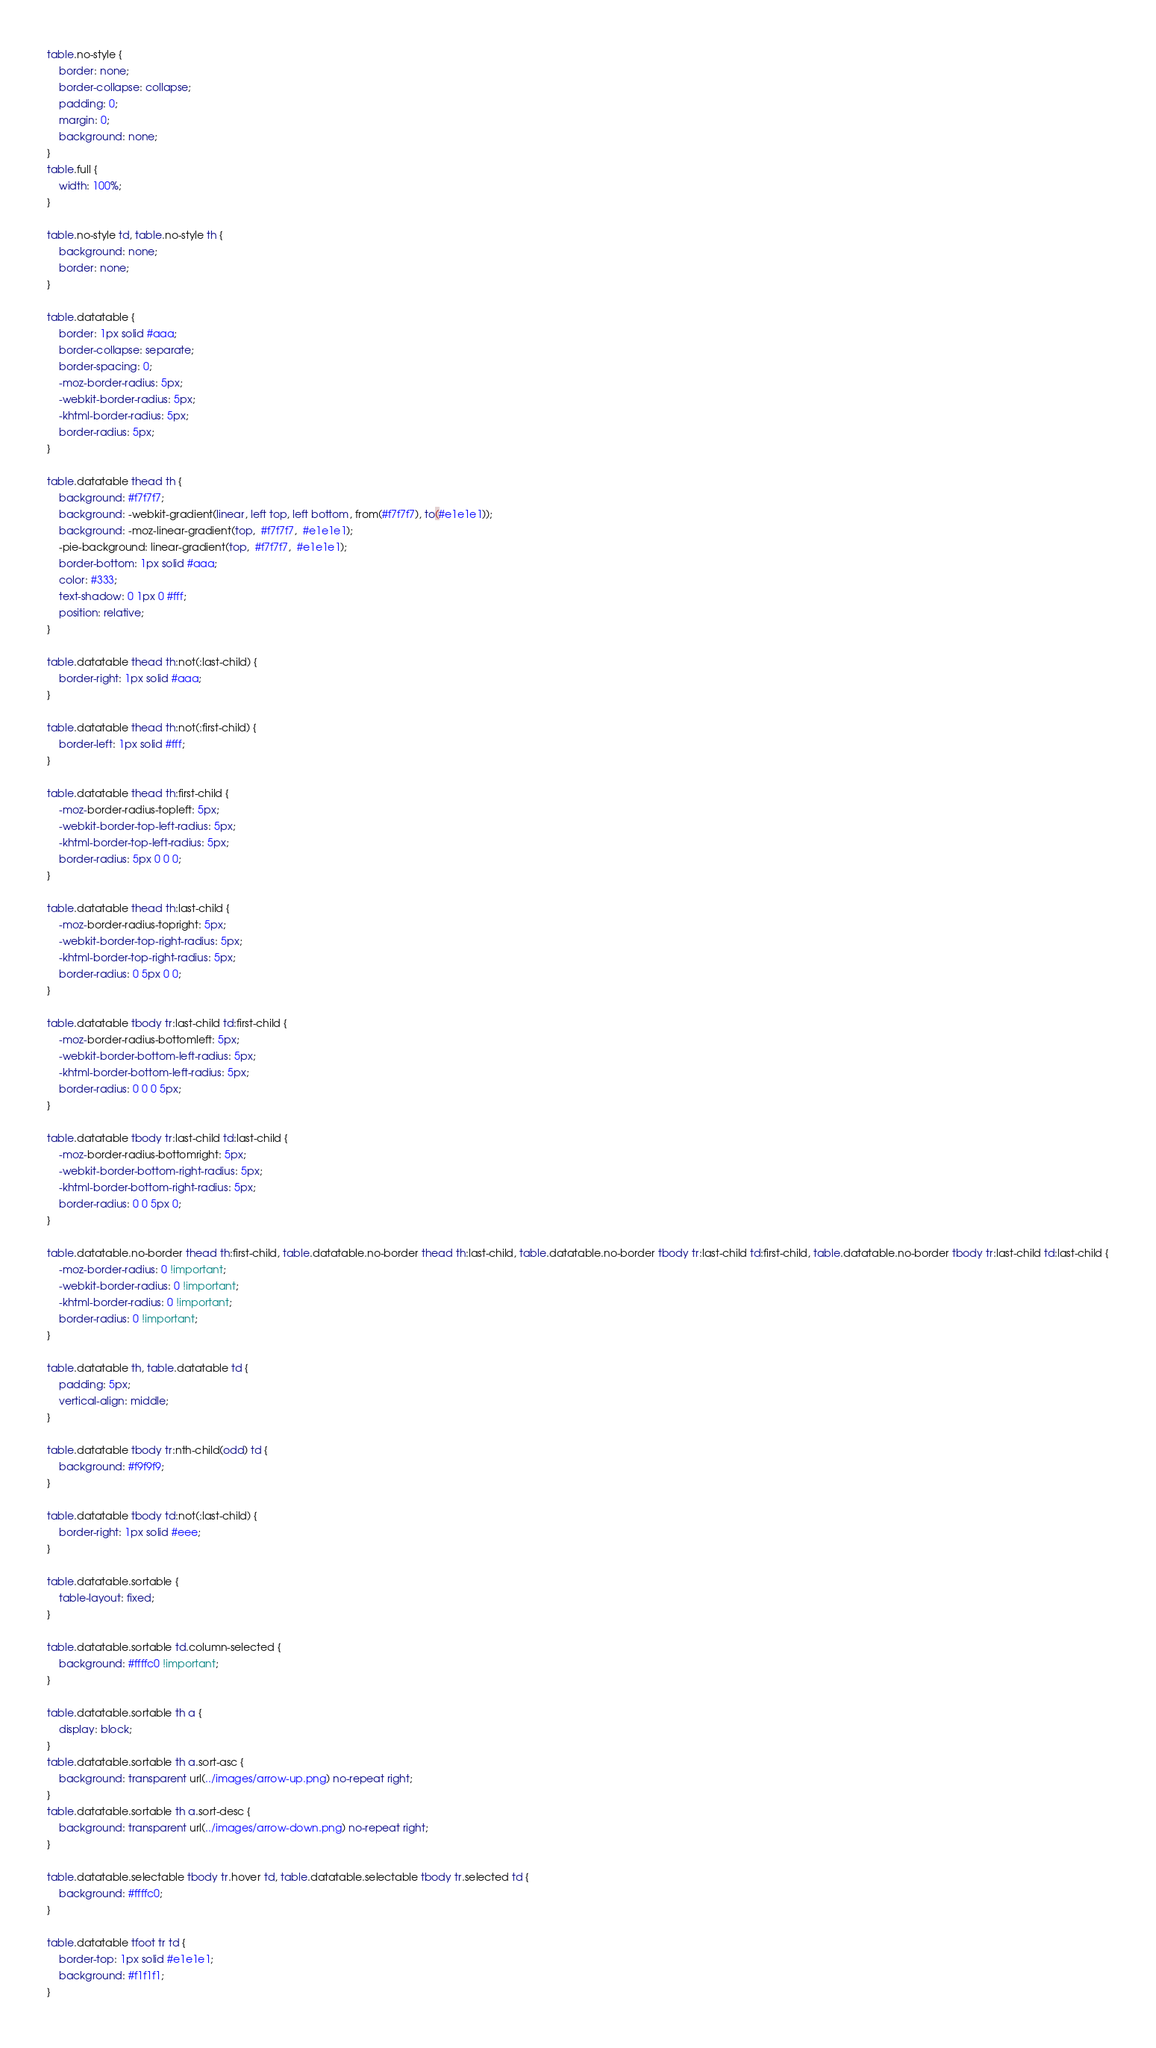<code> <loc_0><loc_0><loc_500><loc_500><_CSS_>table.no-style {
    border: none;
    border-collapse: collapse;
    padding: 0;
    margin: 0;
    background: none;
}
table.full {
    width: 100%;
}

table.no-style td, table.no-style th {
    background: none;
    border: none;
}

table.datatable {
    border: 1px solid #aaa;
    border-collapse: separate;
    border-spacing: 0;
    -moz-border-radius: 5px;
    -webkit-border-radius: 5px;
    -khtml-border-radius: 5px;
    border-radius: 5px;
}

table.datatable thead th {
    background: #f7f7f7;
    background: -webkit-gradient(linear, left top, left bottom, from(#f7f7f7), to(#e1e1e1));
    background: -moz-linear-gradient(top,  #f7f7f7,  #e1e1e1);
    -pie-background: linear-gradient(top,  #f7f7f7,  #e1e1e1);
    border-bottom: 1px solid #aaa;
    color: #333;
    text-shadow: 0 1px 0 #fff;
    position: relative;
}

table.datatable thead th:not(:last-child) {
    border-right: 1px solid #aaa;
}

table.datatable thead th:not(:first-child) {
    border-left: 1px solid #fff;
}

table.datatable thead th:first-child {
    -moz-border-radius-topleft: 5px;
    -webkit-border-top-left-radius: 5px;
    -khtml-border-top-left-radius: 5px;
    border-radius: 5px 0 0 0;
}

table.datatable thead th:last-child {
    -moz-border-radius-topright: 5px;
    -webkit-border-top-right-radius: 5px;
    -khtml-border-top-right-radius: 5px;
    border-radius: 0 5px 0 0;
}

table.datatable tbody tr:last-child td:first-child {
    -moz-border-radius-bottomleft: 5px;
    -webkit-border-bottom-left-radius: 5px;
    -khtml-border-bottom-left-radius: 5px;
    border-radius: 0 0 0 5px;
}

table.datatable tbody tr:last-child td:last-child {
    -moz-border-radius-bottomright: 5px;
    -webkit-border-bottom-right-radius: 5px;
    -khtml-border-bottom-right-radius: 5px;
    border-radius: 0 0 5px 0;
}

table.datatable.no-border thead th:first-child, table.datatable.no-border thead th:last-child, table.datatable.no-border tbody tr:last-child td:first-child, table.datatable.no-border tbody tr:last-child td:last-child {
    -moz-border-radius: 0 !important;
    -webkit-border-radius: 0 !important;
    -khtml-border-radius: 0 !important;
    border-radius: 0 !important;
}

table.datatable th, table.datatable td {
    padding: 5px;
    vertical-align: middle;
}

table.datatable tbody tr:nth-child(odd) td {
    background: #f9f9f9;
}

table.datatable tbody td:not(:last-child) {
    border-right: 1px solid #eee;
}

table.datatable.sortable {
    table-layout: fixed;
}

table.datatable.sortable td.column-selected {
    background: #ffffc0 !important;
}

table.datatable.sortable th a {
    display: block;
}
table.datatable.sortable th a.sort-asc {
    background: transparent url(../images/arrow-up.png) no-repeat right;
}
table.datatable.sortable th a.sort-desc {
    background: transparent url(../images/arrow-down.png) no-repeat right;
}

table.datatable.selectable tbody tr.hover td, table.datatable.selectable tbody tr.selected td {
    background: #ffffc0;
}

table.datatable tfoot tr td {
    border-top: 1px solid #e1e1e1;
    background: #f1f1f1;
}
</code> 